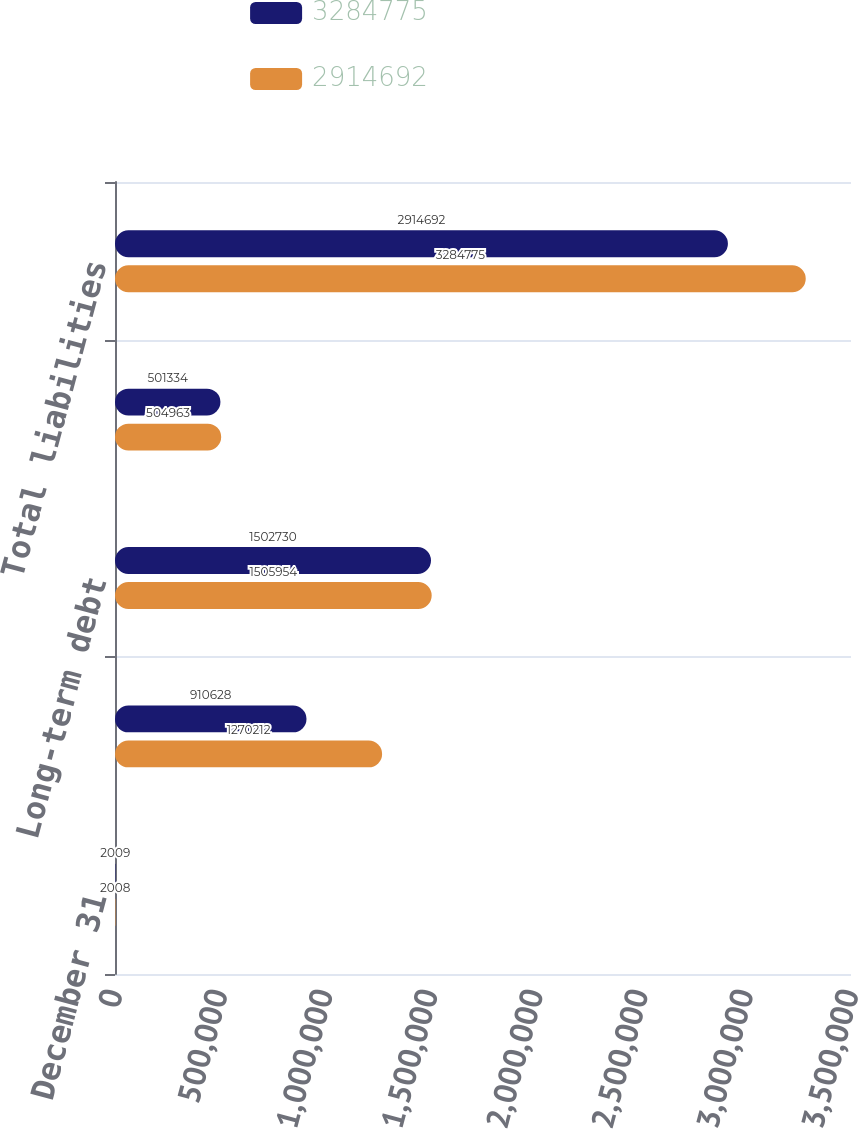<chart> <loc_0><loc_0><loc_500><loc_500><stacked_bar_chart><ecel><fcel>December 31<fcel>Current liabilities<fcel>Long-term debt<fcel>Other long-term liabilities<fcel>Total liabilities<nl><fcel>3.28478e+06<fcel>2009<fcel>910628<fcel>1.50273e+06<fcel>501334<fcel>2.91469e+06<nl><fcel>2.91469e+06<fcel>2008<fcel>1.27021e+06<fcel>1.50595e+06<fcel>504963<fcel>3.28478e+06<nl></chart> 